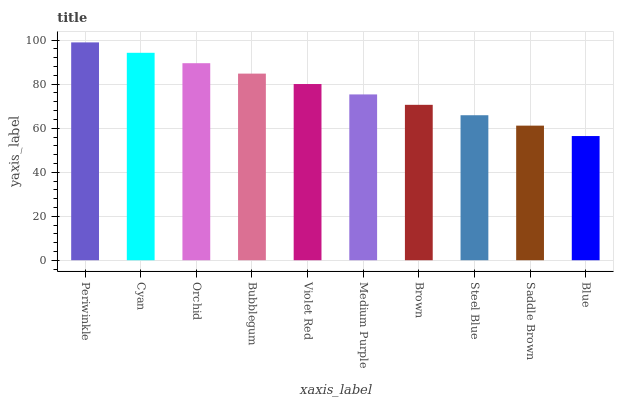Is Blue the minimum?
Answer yes or no. Yes. Is Periwinkle the maximum?
Answer yes or no. Yes. Is Cyan the minimum?
Answer yes or no. No. Is Cyan the maximum?
Answer yes or no. No. Is Periwinkle greater than Cyan?
Answer yes or no. Yes. Is Cyan less than Periwinkle?
Answer yes or no. Yes. Is Cyan greater than Periwinkle?
Answer yes or no. No. Is Periwinkle less than Cyan?
Answer yes or no. No. Is Violet Red the high median?
Answer yes or no. Yes. Is Medium Purple the low median?
Answer yes or no. Yes. Is Cyan the high median?
Answer yes or no. No. Is Cyan the low median?
Answer yes or no. No. 